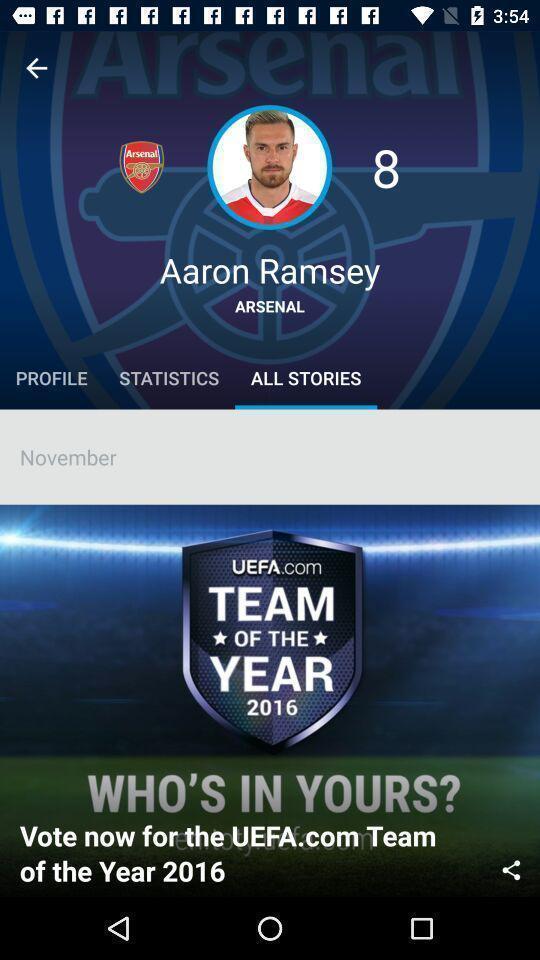Describe the content in this image. Screen showing all the stories. 